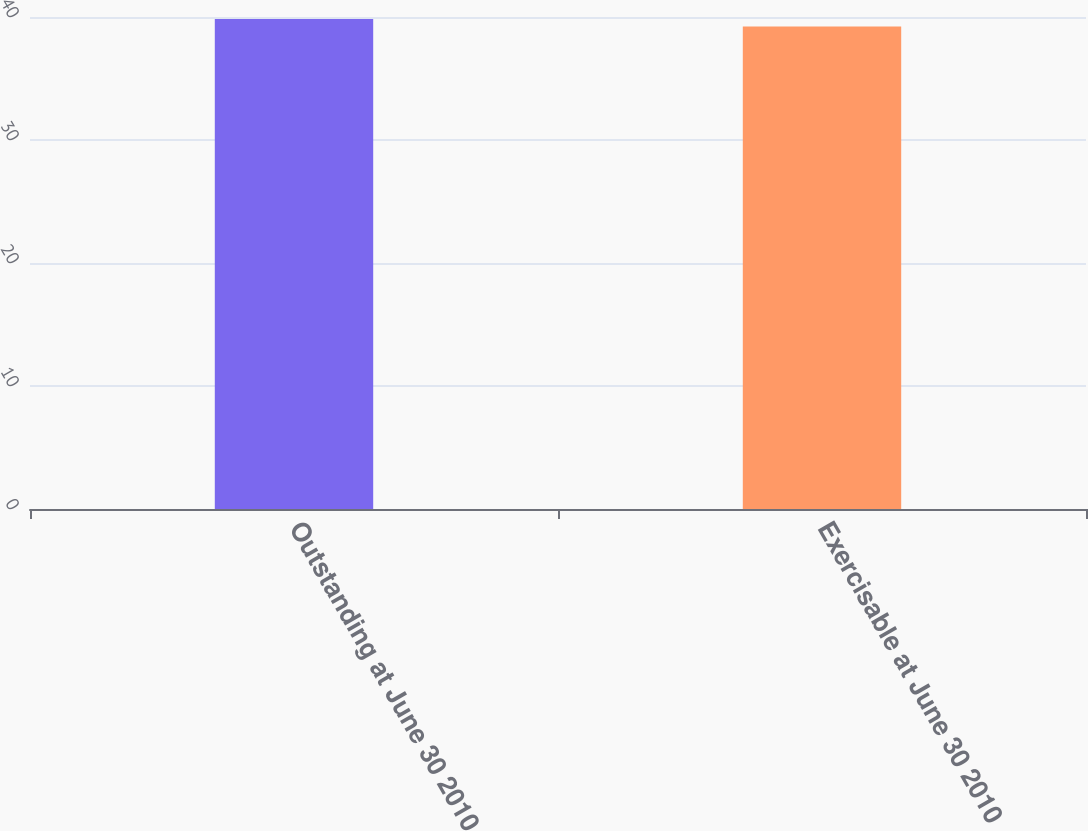<chart> <loc_0><loc_0><loc_500><loc_500><bar_chart><fcel>Outstanding at June 30 2010<fcel>Exercisable at June 30 2010<nl><fcel>39.84<fcel>39.22<nl></chart> 